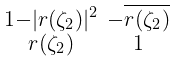<formula> <loc_0><loc_0><loc_500><loc_500>\begin{smallmatrix} 1 - | r ( \zeta _ { 2 } ) | ^ { 2 } & - \overline { r ( \zeta _ { 2 } ) } \\ r ( \zeta _ { 2 } ) & 1 \end{smallmatrix}</formula> 